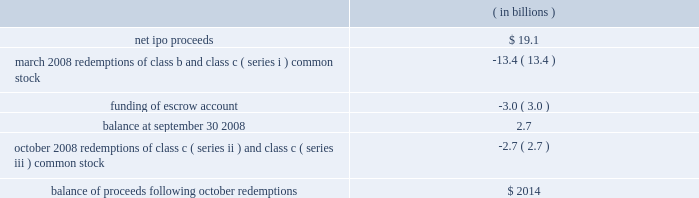Visa inc .
Notes to consolidated financial statements 2014 ( continued ) september 30 , 2008 ( in millions , except as noted ) the table sets forth the use of net proceeds of $ 19.1 billion received in connection with the company 2019s ipo in march 2008: .
Redemptions class b common stock and class c common stock other than class c ( series ii ) common stock 2014march 2008 in march 2008 , the company completed the required redemption of a portion of the class b common stock and class c ( series i ) common stock .
The company used $ 13.4 billion of net proceeds from the ipo to redeem 154738487 shares of class b common stock and 159657751 shares of class c ( series i ) common stock at a redemption price of $ 42.77 per share .
After the redemptions and subject to the restrictions set forth in the company 2019s amended and restated certificate of incorporation ( the 201ccharter 201d ) and the conversion and transfer restrictions below , all outstanding shares of class b common stock are convertible into 175367482 shares of class a common stock and 152009651 shares of class c ( series i , iii and iv ) common stock are convertible into shares of class a common stock on a one-to-one basis .
As a result of the initial funding of the litigation escrow account , the conversion rate applicable to class b common stock was reduced to approximately 0.71 shares of class a common stock for each share of class b common stock , and the 245513385 shares of class b common stock were convertible into 175367482 shares of class a common stock .
The number of shares of class c ( series i , iii and iv ) common stock convertible into shares of class a common stock excludes those class c ( series iii ) common shares that were redeemed in october 2008 , as further described below .
Class c ( series iii ) common stock and class c ( series ii ) common stock 2014october 2008 as anticipated , in october 2008 , the company used $ 1.508 billion of net proceeds from the ipo for the required redemption of 35263585 shares of class c ( series iii ) common stock at a redemption price of $ 42.77 per share as required by the charter .
Following the october 2008 redemption , the remaining 27499203 shares of class c ( series iii ) and class c ( series iv ) common stock outstanding automatically converted into shares of class c ( series i ) common stock on a one-to-one basis .
The company also used $ 1.146 billion of the net proceeds from the ipo to fund the redemption of all class c ( series ii ) common stock in october 2008 .
The redemption price of $ 1.146 billion was adjusted for dividends paid and related interest , par value of related shares redeemed , and the return to visa europe of the class c ( series ii ) common stock subscription receivable outstanding , resulting in a cash payment of $ 1.136 billion .
As a result of the execution of the ipo , visa europe had the option to .
What portion of the ipo net proceeds was used for redemptions of class b and class c ( series i ) common stock on march 2008? 
Computations: (13.4 / 19.1)
Answer: 0.70157. Visa inc .
Notes to consolidated financial statements 2014 ( continued ) september 30 , 2008 ( in millions , except as noted ) the table sets forth the use of net proceeds of $ 19.1 billion received in connection with the company 2019s ipo in march 2008: .
Redemptions class b common stock and class c common stock other than class c ( series ii ) common stock 2014march 2008 in march 2008 , the company completed the required redemption of a portion of the class b common stock and class c ( series i ) common stock .
The company used $ 13.4 billion of net proceeds from the ipo to redeem 154738487 shares of class b common stock and 159657751 shares of class c ( series i ) common stock at a redemption price of $ 42.77 per share .
After the redemptions and subject to the restrictions set forth in the company 2019s amended and restated certificate of incorporation ( the 201ccharter 201d ) and the conversion and transfer restrictions below , all outstanding shares of class b common stock are convertible into 175367482 shares of class a common stock and 152009651 shares of class c ( series i , iii and iv ) common stock are convertible into shares of class a common stock on a one-to-one basis .
As a result of the initial funding of the litigation escrow account , the conversion rate applicable to class b common stock was reduced to approximately 0.71 shares of class a common stock for each share of class b common stock , and the 245513385 shares of class b common stock were convertible into 175367482 shares of class a common stock .
The number of shares of class c ( series i , iii and iv ) common stock convertible into shares of class a common stock excludes those class c ( series iii ) common shares that were redeemed in october 2008 , as further described below .
Class c ( series iii ) common stock and class c ( series ii ) common stock 2014october 2008 as anticipated , in october 2008 , the company used $ 1.508 billion of net proceeds from the ipo for the required redemption of 35263585 shares of class c ( series iii ) common stock at a redemption price of $ 42.77 per share as required by the charter .
Following the october 2008 redemption , the remaining 27499203 shares of class c ( series iii ) and class c ( series iv ) common stock outstanding automatically converted into shares of class c ( series i ) common stock on a one-to-one basis .
The company also used $ 1.146 billion of the net proceeds from the ipo to fund the redemption of all class c ( series ii ) common stock in october 2008 .
The redemption price of $ 1.146 billion was adjusted for dividends paid and related interest , par value of related shares redeemed , and the return to visa europe of the class c ( series ii ) common stock subscription receivable outstanding , resulting in a cash payment of $ 1.136 billion .
As a result of the execution of the ipo , visa europe had the option to .
What portion of the ipo net proceeds was used for funding the of escrow account? 
Computations: (3 / 19.1)
Answer: 0.15707. 